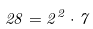Convert formula to latex. <formula><loc_0><loc_0><loc_500><loc_500>2 8 = 2 ^ { 2 } \cdot 7</formula> 